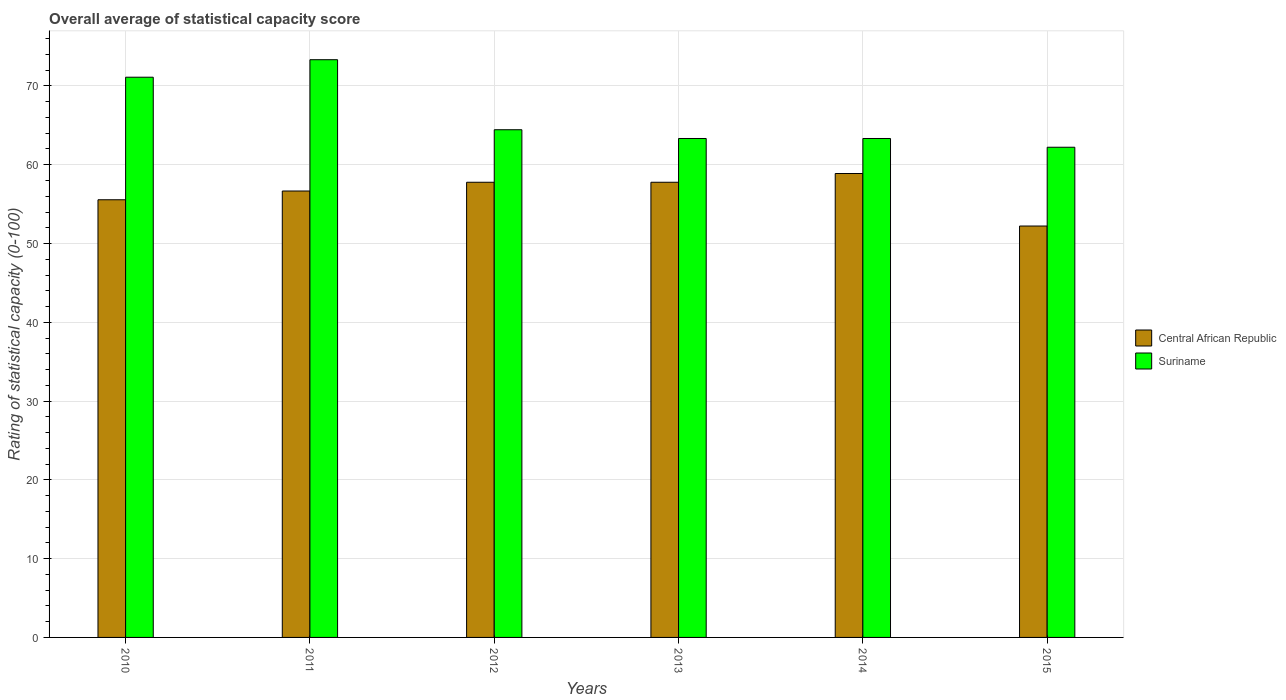How many different coloured bars are there?
Provide a short and direct response. 2. Are the number of bars on each tick of the X-axis equal?
Ensure brevity in your answer.  Yes. How many bars are there on the 5th tick from the left?
Provide a succinct answer. 2. How many bars are there on the 1st tick from the right?
Offer a very short reply. 2. What is the label of the 1st group of bars from the left?
Your answer should be compact. 2010. What is the rating of statistical capacity in Suriname in 2015?
Your response must be concise. 62.22. Across all years, what is the maximum rating of statistical capacity in Central African Republic?
Provide a succinct answer. 58.89. Across all years, what is the minimum rating of statistical capacity in Suriname?
Keep it short and to the point. 62.22. In which year was the rating of statistical capacity in Central African Republic maximum?
Keep it short and to the point. 2014. In which year was the rating of statistical capacity in Central African Republic minimum?
Give a very brief answer. 2015. What is the total rating of statistical capacity in Central African Republic in the graph?
Make the answer very short. 338.89. What is the difference between the rating of statistical capacity in Suriname in 2010 and that in 2014?
Provide a short and direct response. 7.78. What is the difference between the rating of statistical capacity in Suriname in 2011 and the rating of statistical capacity in Central African Republic in 2015?
Your response must be concise. 21.11. What is the average rating of statistical capacity in Central African Republic per year?
Give a very brief answer. 56.48. In the year 2014, what is the difference between the rating of statistical capacity in Central African Republic and rating of statistical capacity in Suriname?
Keep it short and to the point. -4.44. In how many years, is the rating of statistical capacity in Central African Republic greater than 68?
Provide a succinct answer. 0. What is the ratio of the rating of statistical capacity in Suriname in 2010 to that in 2013?
Offer a very short reply. 1.12. What is the difference between the highest and the second highest rating of statistical capacity in Central African Republic?
Your answer should be very brief. 1.11. What is the difference between the highest and the lowest rating of statistical capacity in Central African Republic?
Your response must be concise. 6.67. Is the sum of the rating of statistical capacity in Central African Republic in 2011 and 2013 greater than the maximum rating of statistical capacity in Suriname across all years?
Your answer should be very brief. Yes. What does the 2nd bar from the left in 2011 represents?
Give a very brief answer. Suriname. What does the 2nd bar from the right in 2011 represents?
Make the answer very short. Central African Republic. What is the difference between two consecutive major ticks on the Y-axis?
Ensure brevity in your answer.  10. Are the values on the major ticks of Y-axis written in scientific E-notation?
Give a very brief answer. No. Does the graph contain any zero values?
Make the answer very short. No. Does the graph contain grids?
Your answer should be compact. Yes. Where does the legend appear in the graph?
Keep it short and to the point. Center right. How many legend labels are there?
Give a very brief answer. 2. How are the legend labels stacked?
Your answer should be compact. Vertical. What is the title of the graph?
Keep it short and to the point. Overall average of statistical capacity score. What is the label or title of the Y-axis?
Provide a succinct answer. Rating of statistical capacity (0-100). What is the Rating of statistical capacity (0-100) in Central African Republic in 2010?
Offer a terse response. 55.56. What is the Rating of statistical capacity (0-100) in Suriname in 2010?
Ensure brevity in your answer.  71.11. What is the Rating of statistical capacity (0-100) of Central African Republic in 2011?
Provide a succinct answer. 56.67. What is the Rating of statistical capacity (0-100) of Suriname in 2011?
Keep it short and to the point. 73.33. What is the Rating of statistical capacity (0-100) of Central African Republic in 2012?
Your response must be concise. 57.78. What is the Rating of statistical capacity (0-100) of Suriname in 2012?
Ensure brevity in your answer.  64.44. What is the Rating of statistical capacity (0-100) in Central African Republic in 2013?
Provide a short and direct response. 57.78. What is the Rating of statistical capacity (0-100) of Suriname in 2013?
Your response must be concise. 63.33. What is the Rating of statistical capacity (0-100) of Central African Republic in 2014?
Keep it short and to the point. 58.89. What is the Rating of statistical capacity (0-100) of Suriname in 2014?
Your response must be concise. 63.33. What is the Rating of statistical capacity (0-100) in Central African Republic in 2015?
Your response must be concise. 52.22. What is the Rating of statistical capacity (0-100) in Suriname in 2015?
Provide a short and direct response. 62.22. Across all years, what is the maximum Rating of statistical capacity (0-100) of Central African Republic?
Keep it short and to the point. 58.89. Across all years, what is the maximum Rating of statistical capacity (0-100) in Suriname?
Keep it short and to the point. 73.33. Across all years, what is the minimum Rating of statistical capacity (0-100) in Central African Republic?
Give a very brief answer. 52.22. Across all years, what is the minimum Rating of statistical capacity (0-100) of Suriname?
Your answer should be very brief. 62.22. What is the total Rating of statistical capacity (0-100) in Central African Republic in the graph?
Ensure brevity in your answer.  338.89. What is the total Rating of statistical capacity (0-100) in Suriname in the graph?
Offer a very short reply. 397.78. What is the difference between the Rating of statistical capacity (0-100) of Central African Republic in 2010 and that in 2011?
Provide a succinct answer. -1.11. What is the difference between the Rating of statistical capacity (0-100) in Suriname in 2010 and that in 2011?
Ensure brevity in your answer.  -2.22. What is the difference between the Rating of statistical capacity (0-100) in Central African Republic in 2010 and that in 2012?
Your answer should be compact. -2.22. What is the difference between the Rating of statistical capacity (0-100) in Central African Republic in 2010 and that in 2013?
Make the answer very short. -2.22. What is the difference between the Rating of statistical capacity (0-100) of Suriname in 2010 and that in 2013?
Offer a terse response. 7.78. What is the difference between the Rating of statistical capacity (0-100) in Central African Republic in 2010 and that in 2014?
Keep it short and to the point. -3.33. What is the difference between the Rating of statistical capacity (0-100) in Suriname in 2010 and that in 2014?
Provide a succinct answer. 7.78. What is the difference between the Rating of statistical capacity (0-100) of Central African Republic in 2010 and that in 2015?
Provide a short and direct response. 3.33. What is the difference between the Rating of statistical capacity (0-100) in Suriname in 2010 and that in 2015?
Make the answer very short. 8.89. What is the difference between the Rating of statistical capacity (0-100) in Central African Republic in 2011 and that in 2012?
Your answer should be very brief. -1.11. What is the difference between the Rating of statistical capacity (0-100) in Suriname in 2011 and that in 2012?
Your answer should be compact. 8.89. What is the difference between the Rating of statistical capacity (0-100) in Central African Republic in 2011 and that in 2013?
Offer a terse response. -1.11. What is the difference between the Rating of statistical capacity (0-100) of Central African Republic in 2011 and that in 2014?
Your answer should be compact. -2.22. What is the difference between the Rating of statistical capacity (0-100) of Central African Republic in 2011 and that in 2015?
Ensure brevity in your answer.  4.44. What is the difference between the Rating of statistical capacity (0-100) of Suriname in 2011 and that in 2015?
Provide a short and direct response. 11.11. What is the difference between the Rating of statistical capacity (0-100) in Suriname in 2012 and that in 2013?
Ensure brevity in your answer.  1.11. What is the difference between the Rating of statistical capacity (0-100) of Central African Republic in 2012 and that in 2014?
Provide a short and direct response. -1.11. What is the difference between the Rating of statistical capacity (0-100) in Suriname in 2012 and that in 2014?
Ensure brevity in your answer.  1.11. What is the difference between the Rating of statistical capacity (0-100) of Central African Republic in 2012 and that in 2015?
Give a very brief answer. 5.56. What is the difference between the Rating of statistical capacity (0-100) in Suriname in 2012 and that in 2015?
Ensure brevity in your answer.  2.22. What is the difference between the Rating of statistical capacity (0-100) of Central African Republic in 2013 and that in 2014?
Your answer should be compact. -1.11. What is the difference between the Rating of statistical capacity (0-100) in Central African Republic in 2013 and that in 2015?
Give a very brief answer. 5.56. What is the difference between the Rating of statistical capacity (0-100) of Suriname in 2013 and that in 2015?
Offer a terse response. 1.11. What is the difference between the Rating of statistical capacity (0-100) of Central African Republic in 2014 and that in 2015?
Your answer should be very brief. 6.67. What is the difference between the Rating of statistical capacity (0-100) in Central African Republic in 2010 and the Rating of statistical capacity (0-100) in Suriname in 2011?
Your response must be concise. -17.78. What is the difference between the Rating of statistical capacity (0-100) in Central African Republic in 2010 and the Rating of statistical capacity (0-100) in Suriname in 2012?
Ensure brevity in your answer.  -8.89. What is the difference between the Rating of statistical capacity (0-100) in Central African Republic in 2010 and the Rating of statistical capacity (0-100) in Suriname in 2013?
Make the answer very short. -7.78. What is the difference between the Rating of statistical capacity (0-100) of Central African Republic in 2010 and the Rating of statistical capacity (0-100) of Suriname in 2014?
Provide a succinct answer. -7.78. What is the difference between the Rating of statistical capacity (0-100) in Central African Republic in 2010 and the Rating of statistical capacity (0-100) in Suriname in 2015?
Keep it short and to the point. -6.67. What is the difference between the Rating of statistical capacity (0-100) of Central African Republic in 2011 and the Rating of statistical capacity (0-100) of Suriname in 2012?
Provide a succinct answer. -7.78. What is the difference between the Rating of statistical capacity (0-100) in Central African Republic in 2011 and the Rating of statistical capacity (0-100) in Suriname in 2013?
Your response must be concise. -6.67. What is the difference between the Rating of statistical capacity (0-100) of Central African Republic in 2011 and the Rating of statistical capacity (0-100) of Suriname in 2014?
Make the answer very short. -6.67. What is the difference between the Rating of statistical capacity (0-100) of Central African Republic in 2011 and the Rating of statistical capacity (0-100) of Suriname in 2015?
Give a very brief answer. -5.56. What is the difference between the Rating of statistical capacity (0-100) in Central African Republic in 2012 and the Rating of statistical capacity (0-100) in Suriname in 2013?
Keep it short and to the point. -5.56. What is the difference between the Rating of statistical capacity (0-100) of Central African Republic in 2012 and the Rating of statistical capacity (0-100) of Suriname in 2014?
Offer a terse response. -5.56. What is the difference between the Rating of statistical capacity (0-100) of Central African Republic in 2012 and the Rating of statistical capacity (0-100) of Suriname in 2015?
Your answer should be compact. -4.44. What is the difference between the Rating of statistical capacity (0-100) of Central African Republic in 2013 and the Rating of statistical capacity (0-100) of Suriname in 2014?
Provide a short and direct response. -5.56. What is the difference between the Rating of statistical capacity (0-100) in Central African Republic in 2013 and the Rating of statistical capacity (0-100) in Suriname in 2015?
Your answer should be compact. -4.44. What is the difference between the Rating of statistical capacity (0-100) in Central African Republic in 2014 and the Rating of statistical capacity (0-100) in Suriname in 2015?
Provide a short and direct response. -3.33. What is the average Rating of statistical capacity (0-100) in Central African Republic per year?
Give a very brief answer. 56.48. What is the average Rating of statistical capacity (0-100) of Suriname per year?
Your answer should be compact. 66.3. In the year 2010, what is the difference between the Rating of statistical capacity (0-100) of Central African Republic and Rating of statistical capacity (0-100) of Suriname?
Make the answer very short. -15.56. In the year 2011, what is the difference between the Rating of statistical capacity (0-100) of Central African Republic and Rating of statistical capacity (0-100) of Suriname?
Give a very brief answer. -16.67. In the year 2012, what is the difference between the Rating of statistical capacity (0-100) of Central African Republic and Rating of statistical capacity (0-100) of Suriname?
Provide a short and direct response. -6.67. In the year 2013, what is the difference between the Rating of statistical capacity (0-100) in Central African Republic and Rating of statistical capacity (0-100) in Suriname?
Offer a very short reply. -5.56. In the year 2014, what is the difference between the Rating of statistical capacity (0-100) of Central African Republic and Rating of statistical capacity (0-100) of Suriname?
Provide a succinct answer. -4.44. What is the ratio of the Rating of statistical capacity (0-100) of Central African Republic in 2010 to that in 2011?
Your response must be concise. 0.98. What is the ratio of the Rating of statistical capacity (0-100) in Suriname in 2010 to that in 2011?
Your answer should be very brief. 0.97. What is the ratio of the Rating of statistical capacity (0-100) of Central African Republic in 2010 to that in 2012?
Keep it short and to the point. 0.96. What is the ratio of the Rating of statistical capacity (0-100) of Suriname in 2010 to that in 2012?
Ensure brevity in your answer.  1.1. What is the ratio of the Rating of statistical capacity (0-100) in Central African Republic in 2010 to that in 2013?
Ensure brevity in your answer.  0.96. What is the ratio of the Rating of statistical capacity (0-100) of Suriname in 2010 to that in 2013?
Your answer should be compact. 1.12. What is the ratio of the Rating of statistical capacity (0-100) in Central African Republic in 2010 to that in 2014?
Make the answer very short. 0.94. What is the ratio of the Rating of statistical capacity (0-100) in Suriname in 2010 to that in 2014?
Ensure brevity in your answer.  1.12. What is the ratio of the Rating of statistical capacity (0-100) in Central African Republic in 2010 to that in 2015?
Your answer should be very brief. 1.06. What is the ratio of the Rating of statistical capacity (0-100) in Central African Republic in 2011 to that in 2012?
Your answer should be very brief. 0.98. What is the ratio of the Rating of statistical capacity (0-100) in Suriname in 2011 to that in 2012?
Ensure brevity in your answer.  1.14. What is the ratio of the Rating of statistical capacity (0-100) of Central African Republic in 2011 to that in 2013?
Provide a short and direct response. 0.98. What is the ratio of the Rating of statistical capacity (0-100) in Suriname in 2011 to that in 2013?
Make the answer very short. 1.16. What is the ratio of the Rating of statistical capacity (0-100) of Central African Republic in 2011 to that in 2014?
Provide a succinct answer. 0.96. What is the ratio of the Rating of statistical capacity (0-100) of Suriname in 2011 to that in 2014?
Your response must be concise. 1.16. What is the ratio of the Rating of statistical capacity (0-100) of Central African Republic in 2011 to that in 2015?
Provide a short and direct response. 1.09. What is the ratio of the Rating of statistical capacity (0-100) in Suriname in 2011 to that in 2015?
Provide a succinct answer. 1.18. What is the ratio of the Rating of statistical capacity (0-100) of Suriname in 2012 to that in 2013?
Keep it short and to the point. 1.02. What is the ratio of the Rating of statistical capacity (0-100) in Central African Republic in 2012 to that in 2014?
Your answer should be compact. 0.98. What is the ratio of the Rating of statistical capacity (0-100) of Suriname in 2012 to that in 2014?
Your answer should be compact. 1.02. What is the ratio of the Rating of statistical capacity (0-100) in Central African Republic in 2012 to that in 2015?
Give a very brief answer. 1.11. What is the ratio of the Rating of statistical capacity (0-100) of Suriname in 2012 to that in 2015?
Provide a succinct answer. 1.04. What is the ratio of the Rating of statistical capacity (0-100) in Central African Republic in 2013 to that in 2014?
Your answer should be compact. 0.98. What is the ratio of the Rating of statistical capacity (0-100) of Central African Republic in 2013 to that in 2015?
Offer a terse response. 1.11. What is the ratio of the Rating of statistical capacity (0-100) of Suriname in 2013 to that in 2015?
Offer a terse response. 1.02. What is the ratio of the Rating of statistical capacity (0-100) in Central African Republic in 2014 to that in 2015?
Provide a succinct answer. 1.13. What is the ratio of the Rating of statistical capacity (0-100) in Suriname in 2014 to that in 2015?
Your response must be concise. 1.02. What is the difference between the highest and the second highest Rating of statistical capacity (0-100) in Central African Republic?
Ensure brevity in your answer.  1.11. What is the difference between the highest and the second highest Rating of statistical capacity (0-100) in Suriname?
Give a very brief answer. 2.22. What is the difference between the highest and the lowest Rating of statistical capacity (0-100) in Central African Republic?
Offer a very short reply. 6.67. What is the difference between the highest and the lowest Rating of statistical capacity (0-100) of Suriname?
Give a very brief answer. 11.11. 